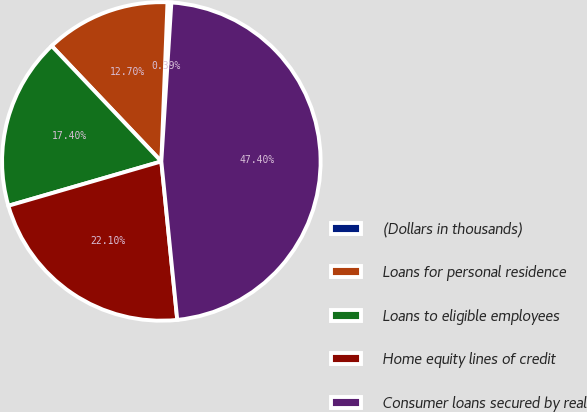Convert chart. <chart><loc_0><loc_0><loc_500><loc_500><pie_chart><fcel>(Dollars in thousands)<fcel>Loans for personal residence<fcel>Loans to eligible employees<fcel>Home equity lines of credit<fcel>Consumer loans secured by real<nl><fcel>0.39%<fcel>12.7%<fcel>17.4%<fcel>22.1%<fcel>47.39%<nl></chart> 